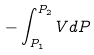<formula> <loc_0><loc_0><loc_500><loc_500>- \int _ { P _ { 1 } } ^ { P _ { 2 } } V d P</formula> 